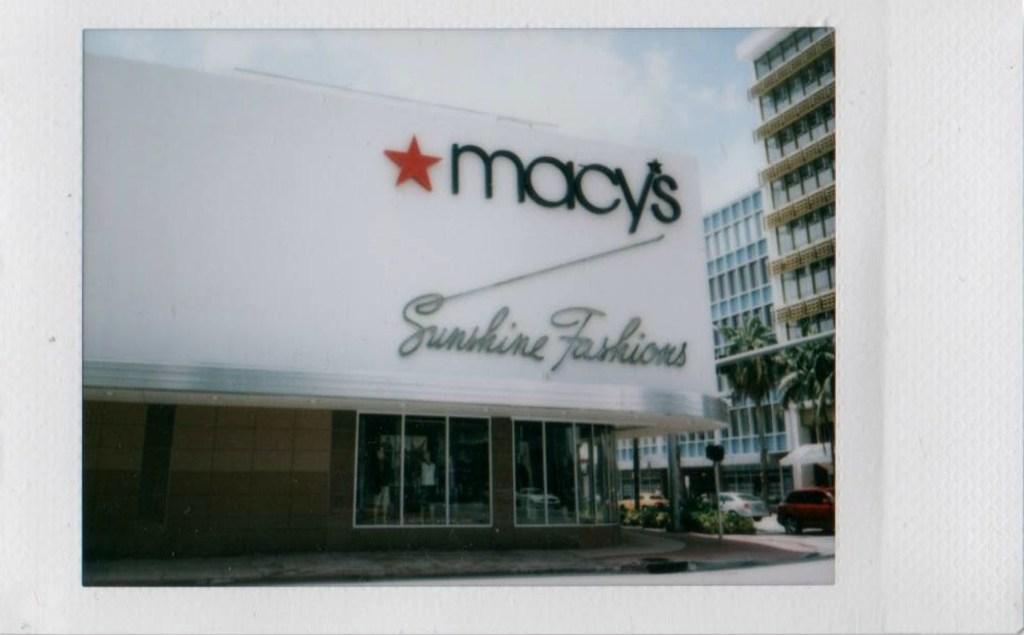How would you summarize this image in a sentence or two? In this picture we can find few buildings, trees, cars and few mannequins. 